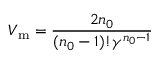Convert formula to latex. <formula><loc_0><loc_0><loc_500><loc_500>V _ { m } = { \frac { 2 n _ { 0 } } { ( n _ { 0 } - 1 ) ! \gamma ^ { n _ { 0 } - 1 } } }</formula> 